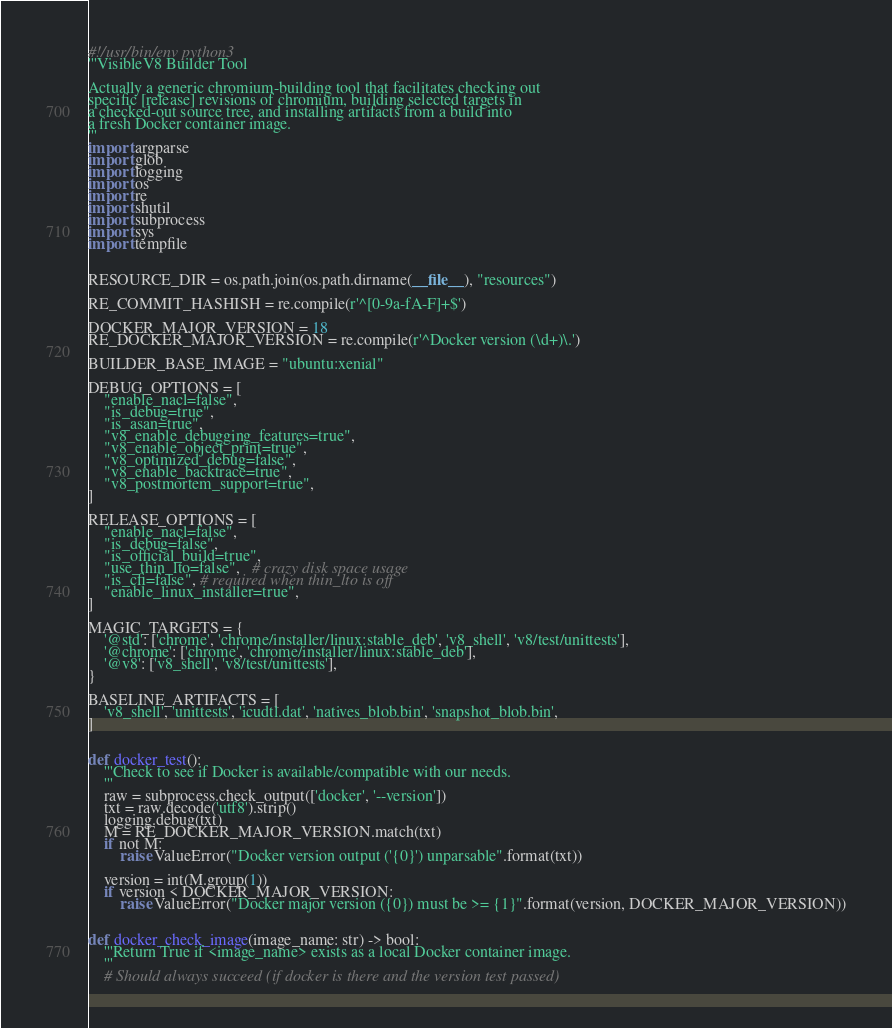<code> <loc_0><loc_0><loc_500><loc_500><_Python_>#!/usr/bin/env python3
'''VisibleV8 Builder Tool

Actually a generic chromium-building tool that facilitates checking out 
specific [release] revisions of chromium, building selected targets in
a checked-out source tree, and installing artifacts from a build into
a fresh Docker container image.
'''
import argparse
import glob
import logging
import os
import re
import shutil
import subprocess
import sys
import tempfile


RESOURCE_DIR = os.path.join(os.path.dirname(__file__), "resources")

RE_COMMIT_HASHISH = re.compile(r'^[0-9a-fA-F]+$')

DOCKER_MAJOR_VERSION = 18
RE_DOCKER_MAJOR_VERSION = re.compile(r'^Docker version (\d+)\.')

BUILDER_BASE_IMAGE = "ubuntu:xenial"

DEBUG_OPTIONS = [
    "enable_nacl=false",
    "is_debug=true",
    "is_asan=true",
    "v8_enable_debugging_features=true",
    "v8_enable_object_print=true",
    "v8_optimized_debug=false",
    "v8_enable_backtrace=true",
    "v8_postmortem_support=true",
]

RELEASE_OPTIONS = [
    "enable_nacl=false",
    "is_debug=false",
    "is_official_build=true",
    "use_thin_lto=false",   # crazy disk space usage
    "is_cfi=false", # required when thin_lto is off
    "enable_linux_installer=true",
]

MAGIC_TARGETS = {
    '@std': ['chrome', 'chrome/installer/linux:stable_deb', 'v8_shell', 'v8/test/unittests'],
    '@chrome': ['chrome', 'chrome/installer/linux:stable_deb'],
    '@v8': ['v8_shell', 'v8/test/unittests'],
}

BASELINE_ARTIFACTS = [
    'v8_shell', 'unittests', 'icudtl.dat', 'natives_blob.bin', 'snapshot_blob.bin',
]


def docker_test():
    '''Check to see if Docker is available/compatible with our needs.
    '''
    raw = subprocess.check_output(['docker', '--version'])
    txt = raw.decode('utf8').strip()
    logging.debug(txt)
    M = RE_DOCKER_MAJOR_VERSION.match(txt)
    if not M:
        raise ValueError("Docker version output ('{0}') unparsable".format(txt))
    
    version = int(M.group(1))
    if version < DOCKER_MAJOR_VERSION:
        raise ValueError("Docker major version ({0}) must be >= {1}".format(version, DOCKER_MAJOR_VERSION))


def docker_check_image(image_name: str) -> bool:
    '''Return True if <image_name> exists as a local Docker container image.
    '''
    # Should always succeed (if docker is there and the version test passed)</code> 